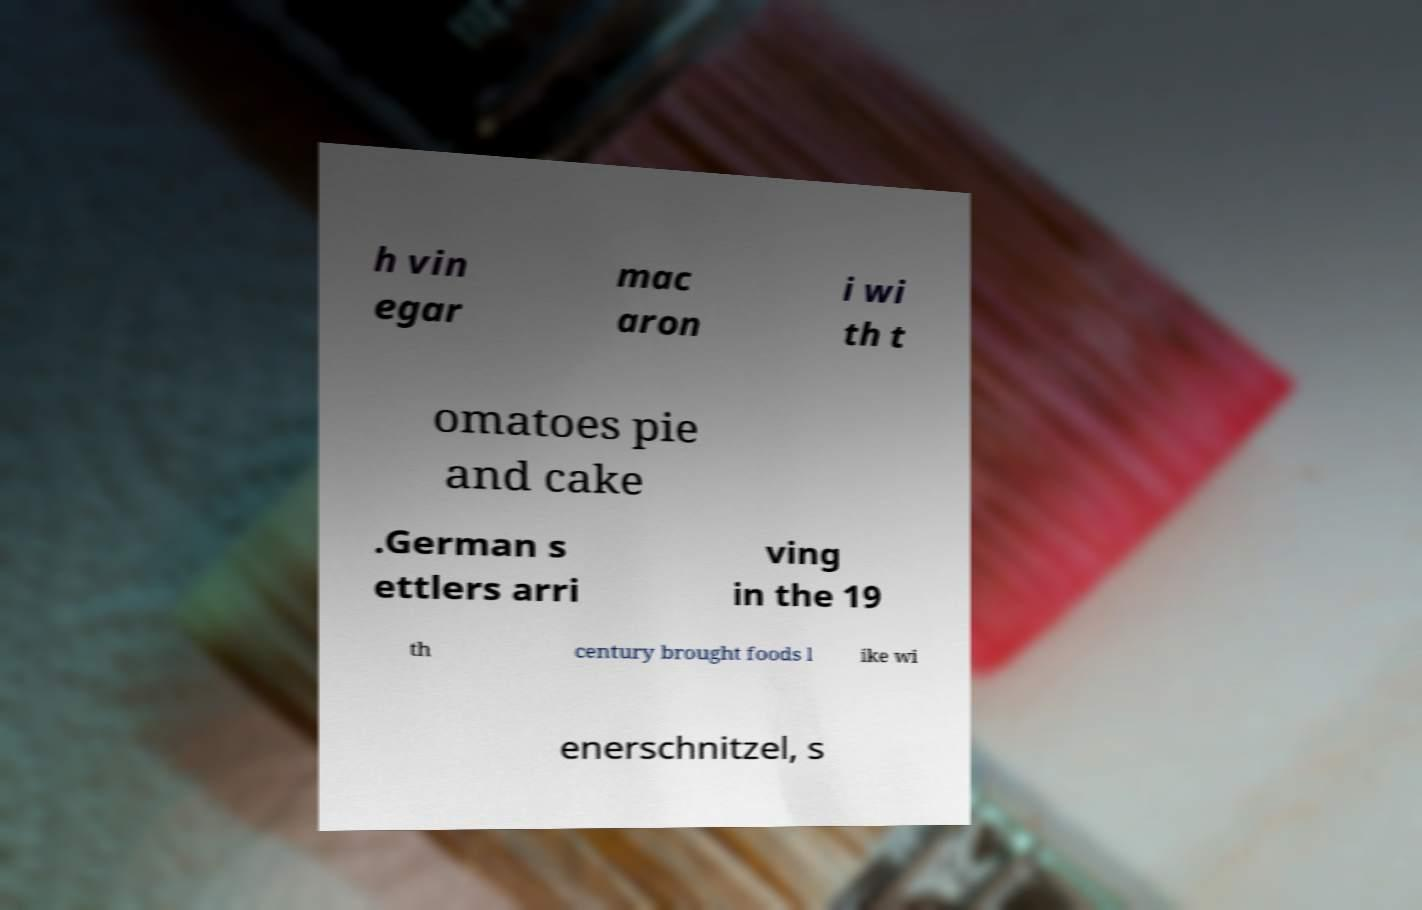Can you accurately transcribe the text from the provided image for me? h vin egar mac aron i wi th t omatoes pie and cake .German s ettlers arri ving in the 19 th century brought foods l ike wi enerschnitzel, s 